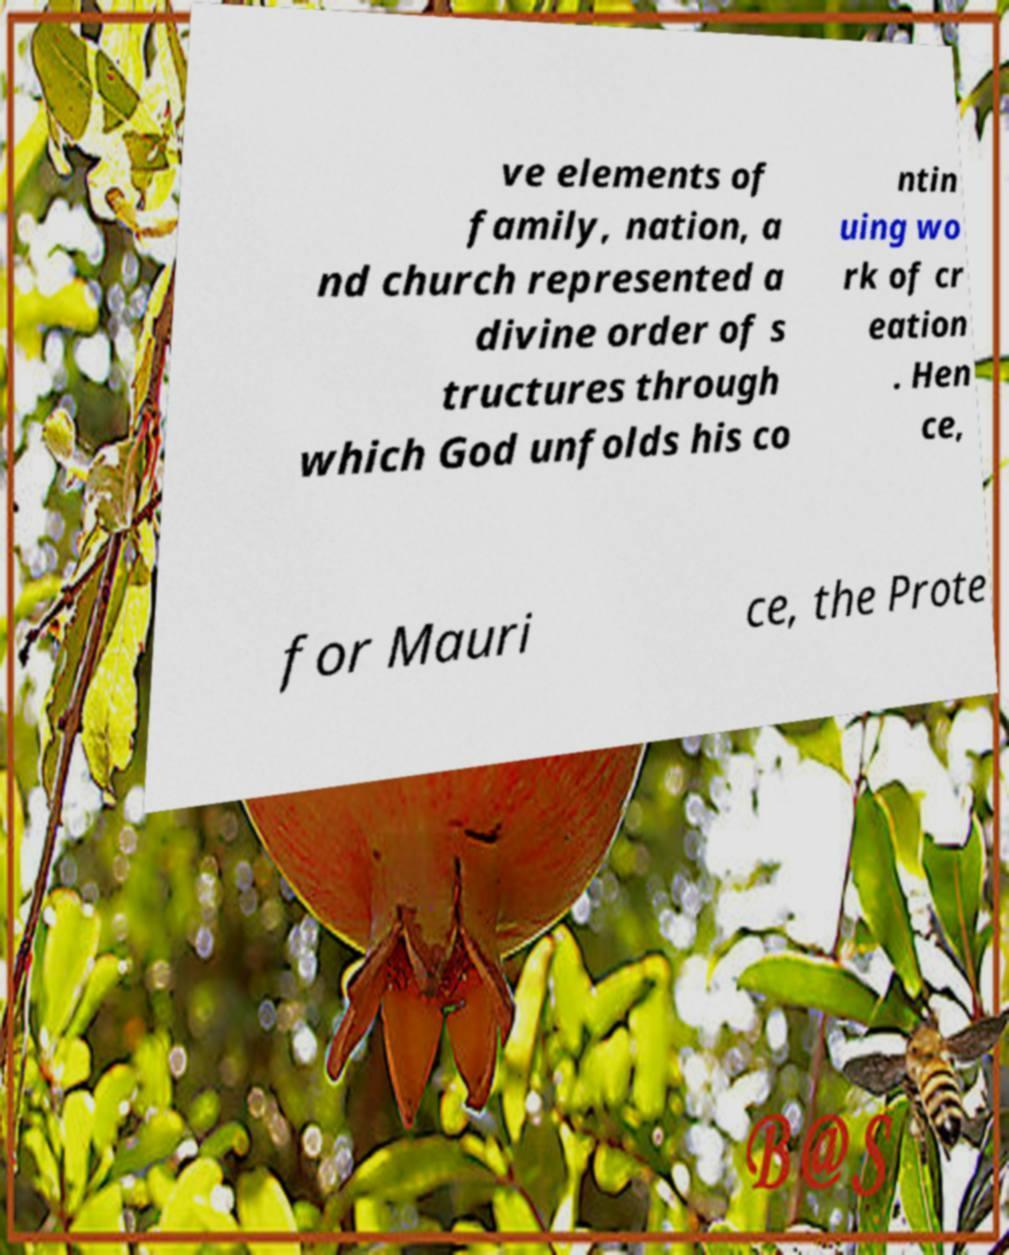Could you extract and type out the text from this image? ve elements of family, nation, a nd church represented a divine order of s tructures through which God unfolds his co ntin uing wo rk of cr eation . Hen ce, for Mauri ce, the Prote 